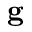<formula> <loc_0><loc_0><loc_500><loc_500>g</formula> 